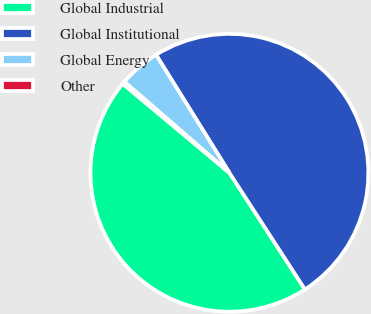Convert chart to OTSL. <chart><loc_0><loc_0><loc_500><loc_500><pie_chart><fcel>Global Industrial<fcel>Global Institutional<fcel>Global Energy<fcel>Other<nl><fcel>45.22%<fcel>49.71%<fcel>4.78%<fcel>0.29%<nl></chart> 